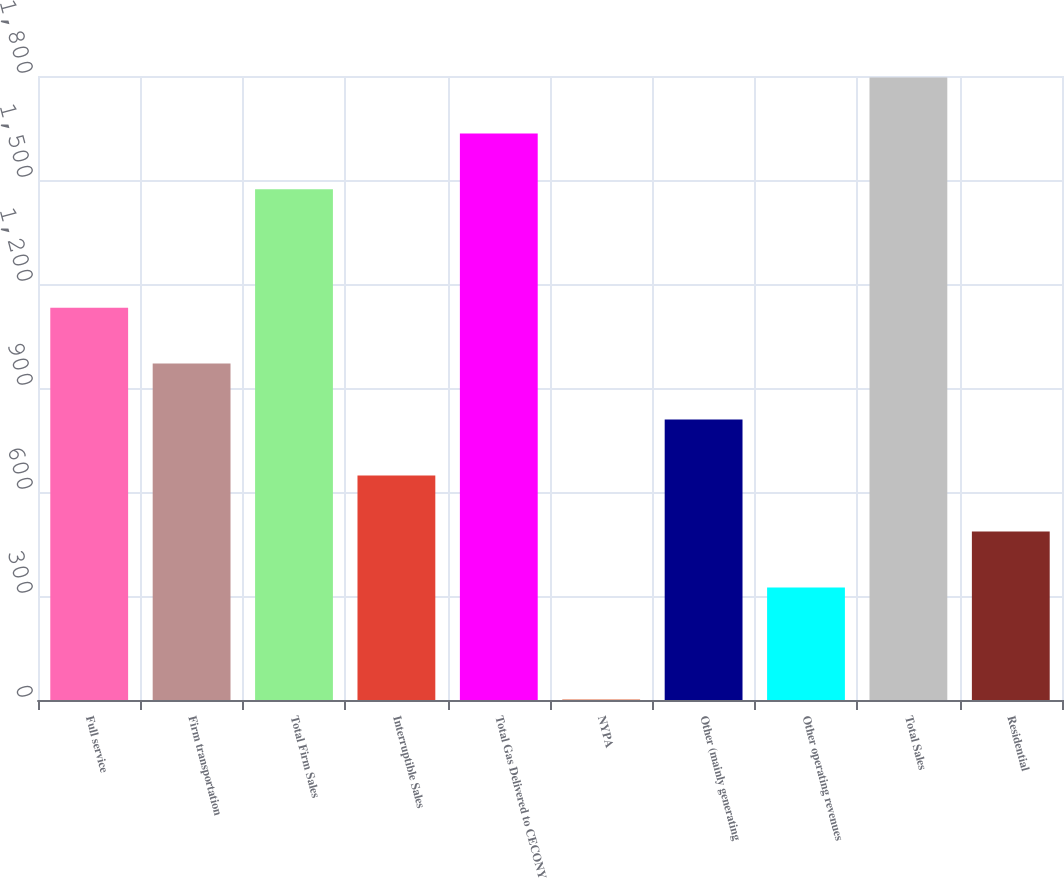Convert chart to OTSL. <chart><loc_0><loc_0><loc_500><loc_500><bar_chart><fcel>Full service<fcel>Firm transportation<fcel>Total Firm Sales<fcel>Interruptible Sales<fcel>Total Gas Delivered to CECONY<fcel>NYPA<fcel>Other (mainly generating<fcel>Other operating revenues<fcel>Total Sales<fcel>Residential<nl><fcel>1131.8<fcel>970.4<fcel>1473<fcel>647.6<fcel>1634.4<fcel>2<fcel>809<fcel>324.8<fcel>1795.8<fcel>486.2<nl></chart> 